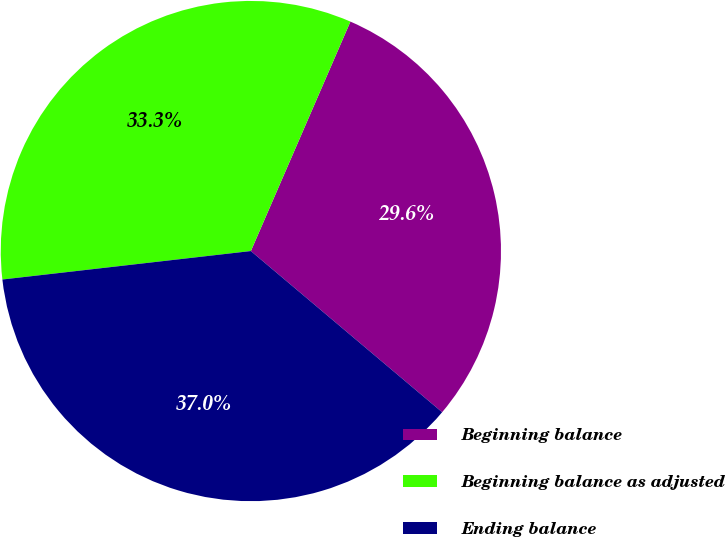<chart> <loc_0><loc_0><loc_500><loc_500><pie_chart><fcel>Beginning balance<fcel>Beginning balance as adjusted<fcel>Ending balance<nl><fcel>29.63%<fcel>33.33%<fcel>37.04%<nl></chart> 